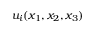<formula> <loc_0><loc_0><loc_500><loc_500>{ u _ { i } } ( x _ { 1 } , x _ { 2 } , x _ { 3 } )</formula> 